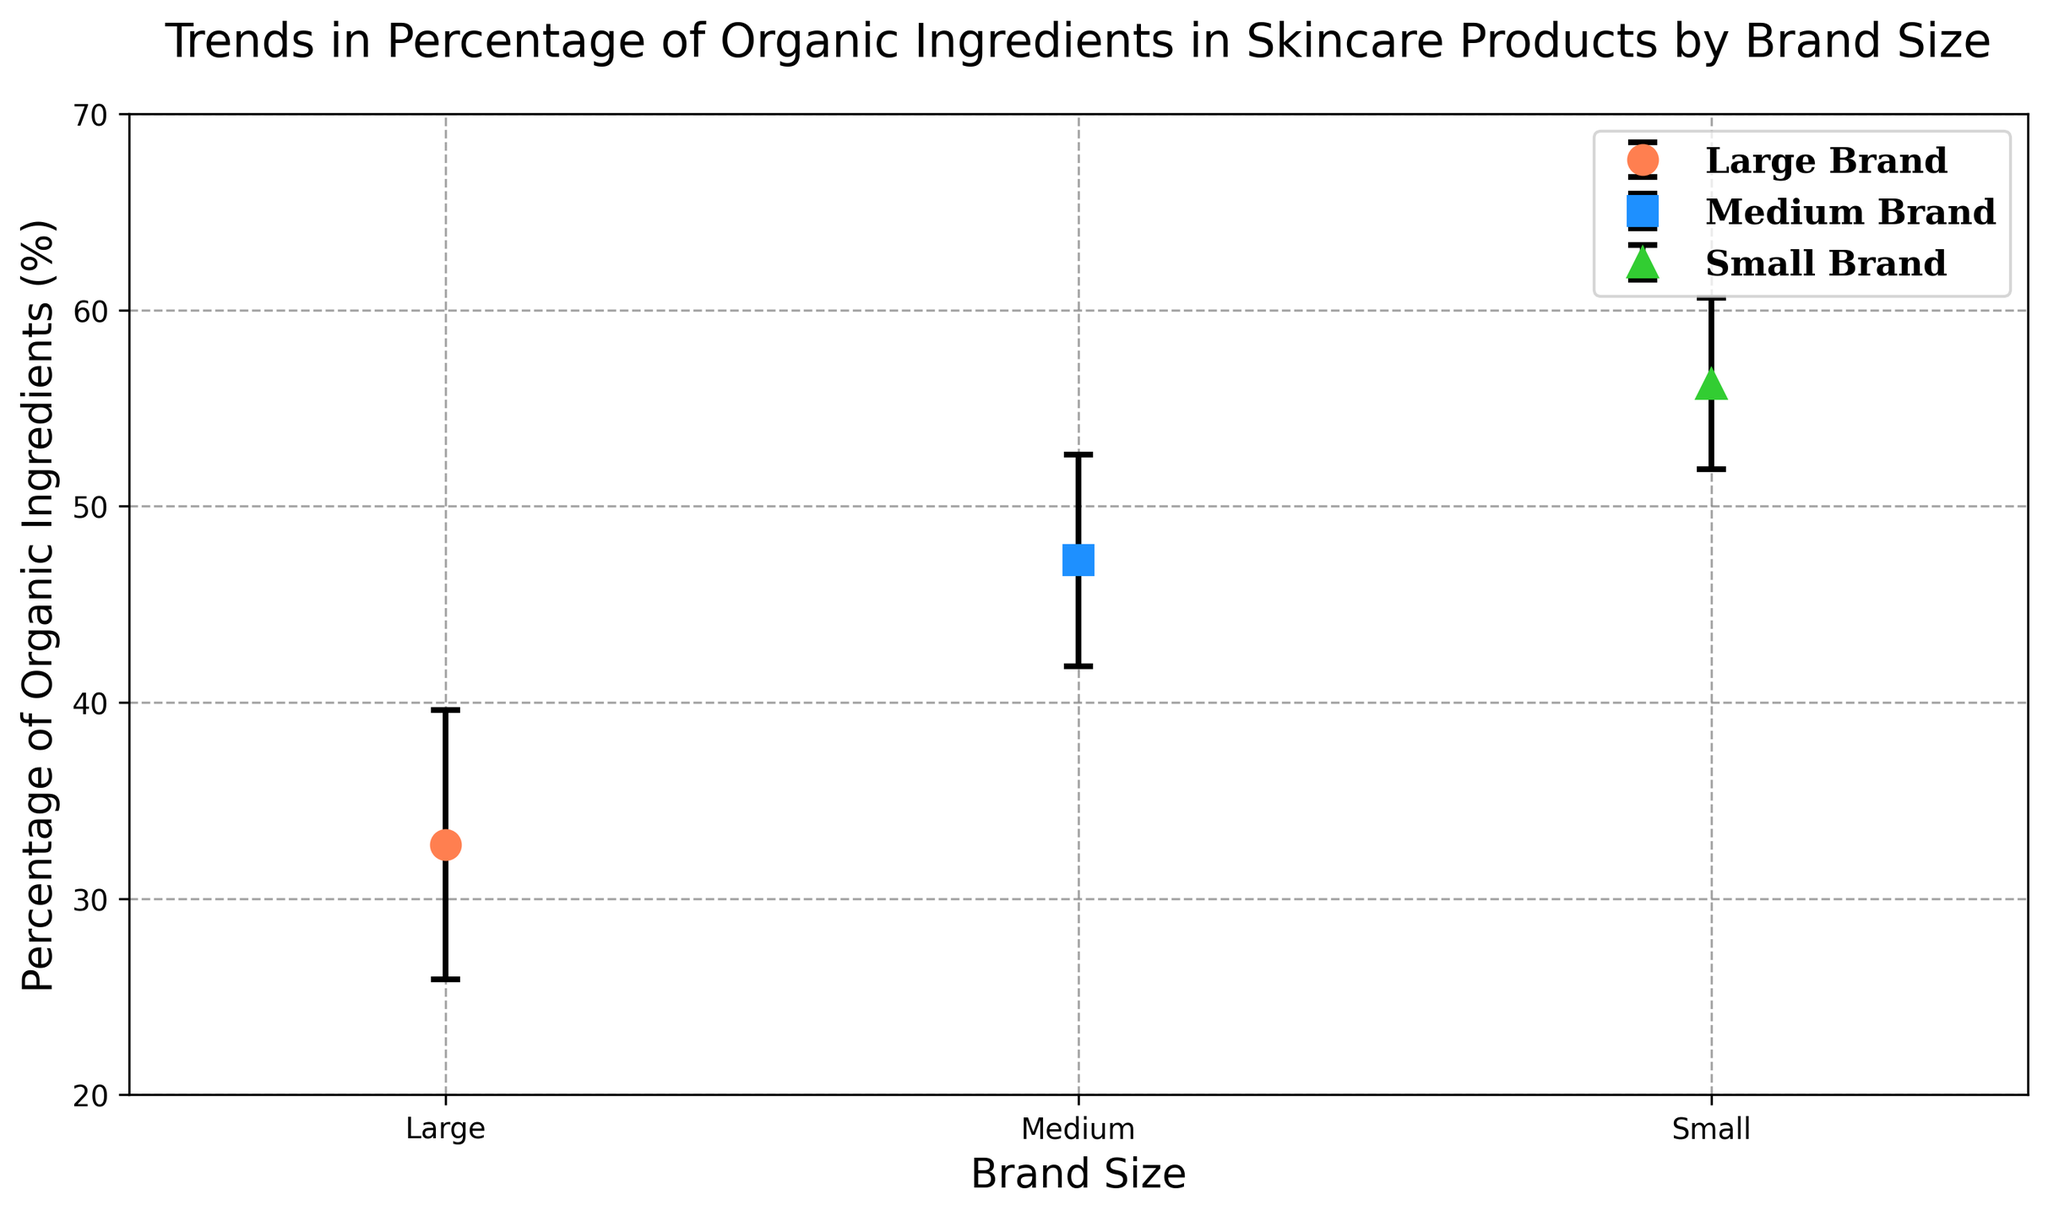Which brand size has the highest average percentage of organic ingredients? Inspect the plot to see where the highest mean value is located. The small brand size has the highest average percentage of organic ingredients, around 56.5%.
Answer: Small Which brand size has the largest standard deviation in the percentage of organic ingredients? The standard deviation values are represented by the error bars. The medium and large brands have larger error bars compared to the small brands. However, the large brand has the largest average standard deviation of around 6.88%.
Answer: Large How much higher is the average percentage of organic ingredients in small brands compared to large brands? Subtract the average percentage of organic ingredients of the large brand (approximately 32.75%) from the small brand (approximately 56.25%). 56.25% - 32.75% = 23.5%.
Answer: 23.5% Which brand size shows the smallest variation in the percentage of organic ingredients? The variation is indicated by the length of the error bars. The small brand size has the shortest error bars, indicating the smallest variation, with an average standard deviation of about 4.37%.
Answer: Small How does the average percentage of organic ingredients in medium brands compare to small brands? Observe the plot to compare the mean values. The average percentage for small brands is around 56.25%, while for medium brands, it is about 47.25%. So, small brands have around 9% more organic ingredients on average compared to medium brands.
Answer: Small brands have 9% more What is the difference between the highest and lowest standard deviations shown in the plot? Identify the highest standard deviation for large brands (around 6.88%) and the lowest for small brands (around 4.38%). Calculate the difference: 6.88% - 4.38% = 2.50%.
Answer: 2.50% Which brand size has the median average percentage of organic ingredients? Arrange the average percentages in ascending order: Large (32.75%), Medium (47.25%), and Small (56.25%). The median value here is the percentage for Medium brands.
Answer: Medium What color represents medium brand sizes in the plot? The legend in the plot indicates that Dodger Blue represents medium brand sizes.
Answer: Dodger Blue 